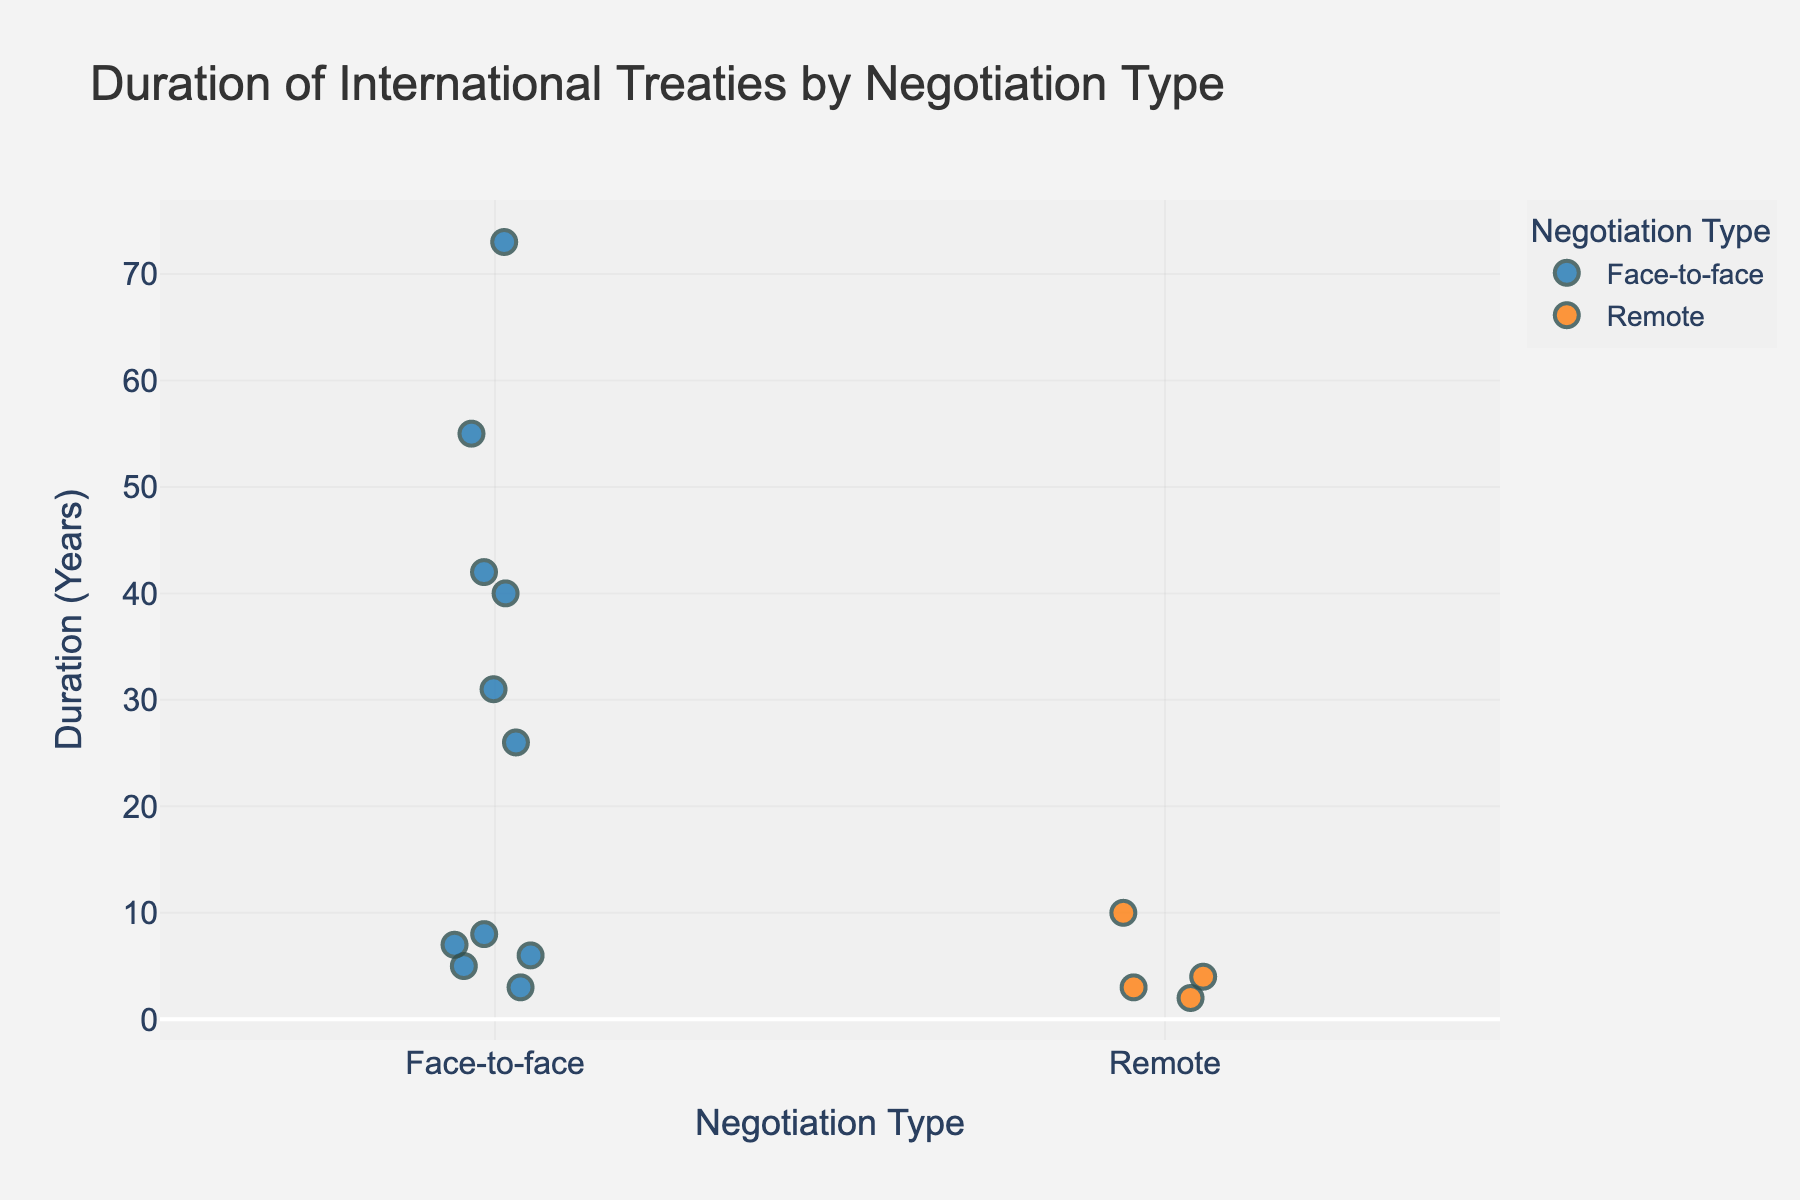What's the title of the figure? The title can be found at the top of the figure, providing a summary of what the figure represents.
Answer: Duration of International Treaties by Negotiation Type How many treaties were negotiated face-to-face? To find this, count the number of data points (markers) on the strip corresponding to the face-to-face negotiation type.
Answer: 11 What is the maximum duration of treaties negotiated remotely? Identify the highest value on the 'duration_years' axis for the 'Remote' category.
Answer: 10 Which negotiation type has a higher average duration of treaties? Calculate the average duration for both face-to-face and remote categories. Sum the durations and divide by the number of treaties for each type to compare. Face-to-face: (5+8+3+6+7+42+31+26+73+55+40)/11 = 26.27; Remote: (10+4+3+2)/4 = 4.75. So, Face-to-face has a higher average.
Answer: Face-to-face Which specific treaty has the longest duration, and what is its negotiation type? Identify the data point with the maximum value on the 'duration_years' axis. The treaty corresponding to this data point is the one with the longest duration.
Answer: Geneva Conventions, Face-to-face How many treaties have a duration of less than 10 years for both negotiation types combined? Count the data points for both categories where the 'duration_years' is less than 10.
Answer: 7 Are there more treaties with a duration greater than 20 years negotiated face-to-face or remotely? Compare the number of treaties in each negotiation type where the 'duration_years' is greater than 20 by counting the data points.
Answer: Face-to-face What is the median duration of face-to-face negotiated treaties? List the durations, sort them, and find the middle value (for an odd number of data points) or the average of the two middle values (for an even number of data points). Sorted durations: [3, 5, 6, 7, 8, 26, 31, 40, 42, 55, 73]. The median is 26.
Answer: 26 What insight can you derive from the strip plot regarding the longevity of treaties based on negotiation types? By observing the spread and central tendency of the data points, it can be seen that treaties negotiated face-to-face tend to have a wider range and potentially longer durations compared to those negotiated remotely.
Answer: Face-to-face treaties vary more and can last longer 